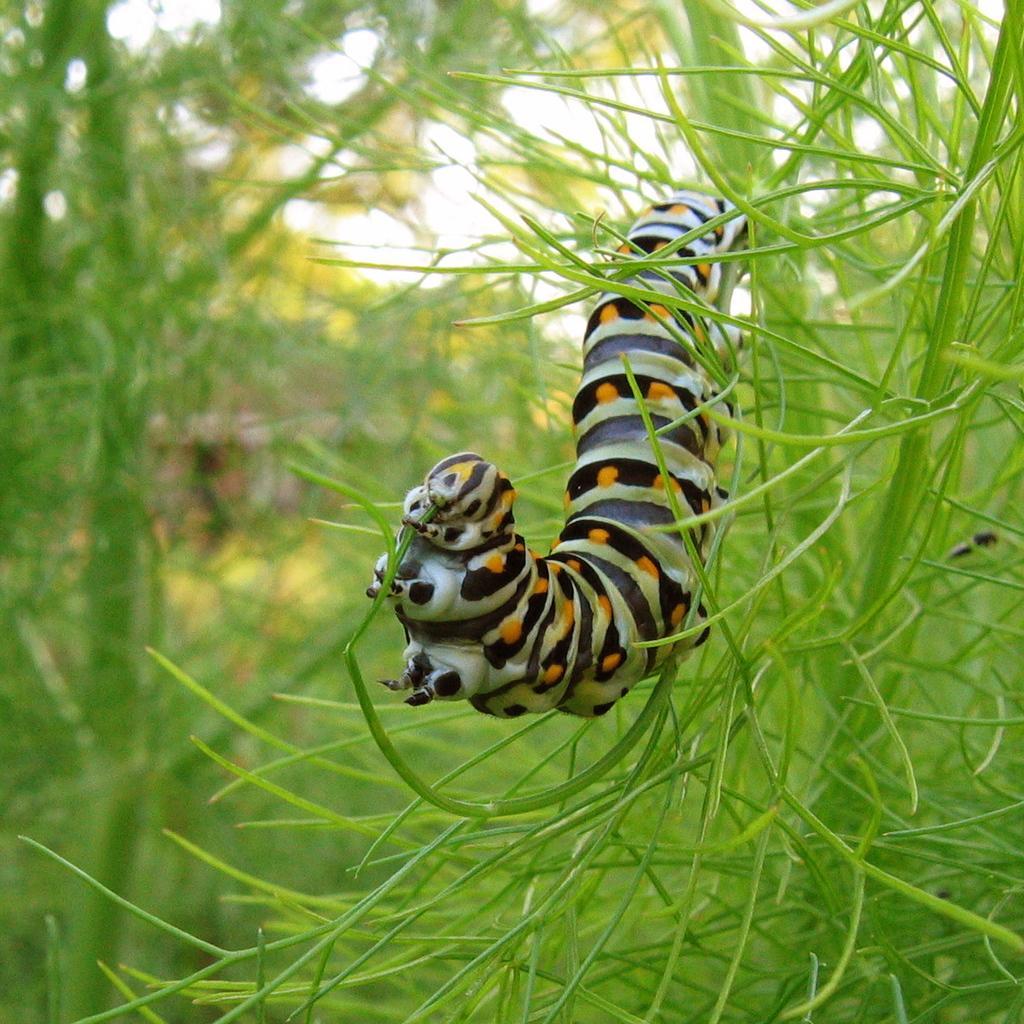Describe this image in one or two sentences. In this picture there is an insect on the plant which is in green color and there is greenery in the background. 